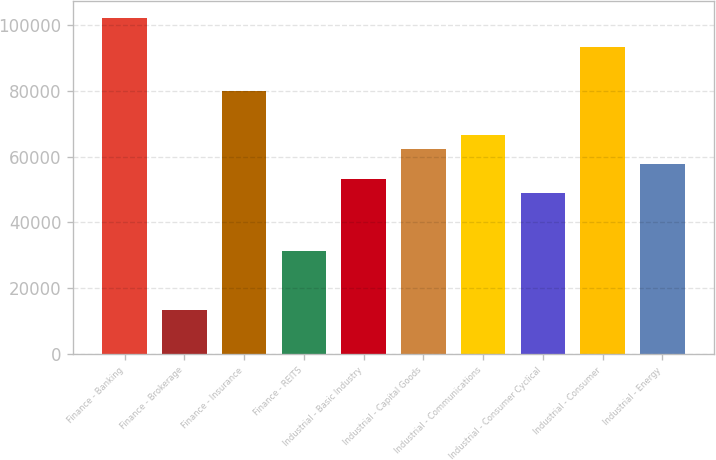Convert chart to OTSL. <chart><loc_0><loc_0><loc_500><loc_500><bar_chart><fcel>Finance - Banking<fcel>Finance - Brokerage<fcel>Finance - Insurance<fcel>Finance - REITS<fcel>Industrial - Basic Industry<fcel>Industrial - Capital Goods<fcel>Industrial - Communications<fcel>Industrial - Consumer Cyclical<fcel>Industrial - Consumer<fcel>Industrial - Energy<nl><fcel>102211<fcel>13412<fcel>80010.9<fcel>31171.7<fcel>53371.4<fcel>62251.2<fcel>66691.1<fcel>48931.4<fcel>93330.7<fcel>57811.3<nl></chart> 